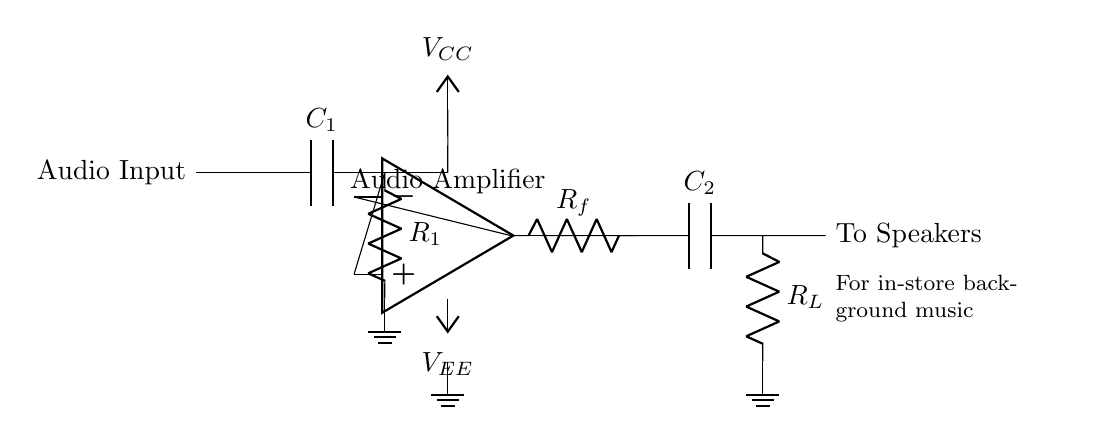What type of amplifier is shown in the circuit? The circuit diagram uses an operational amplifier, which is typically categorized as a voltage amplifier in analog circuits. This can be deduced from the presence of the op-amp symbol, indicating it amplifies the input audio signal.
Answer: operational amplifier What is the value of the input capacitance? The circuit features a capacitor labeled C1, which serves as the input capacitor. The label indicates its function in coupling the audio signal but does not specify a numerical value. Therefore, we can only describe it as capacitance without a given number.
Answer: capacitance Where do the output signals go in the circuit? The output from the op-amp is directed towards a load resistor labeled R_L. This output pathway connects to the speakers, suggesting that the final amplified audio signal is intended for playback, thus elucidating the circuit's purpose.
Answer: to speakers What is the role of the resistors R1 and Rf in this amplifier circuit? R1 serves as a biasing resistor, helping to stabilize the input to the op-amp, while Rf, the feedback resistor, determines the gain of the amplifier based on the ratio between Rf and the other resistors in the feedback loop. This relationship is essential for controlling how much the audio signal is amplified.
Answer: stabilize input and set gain Identify the power supply voltages present in the circuit. The circuit has both positive and negative power supply voltages, denoted as V_CC and V_EE, respectively. These voltages are essential for the operation of the op-amp, providing the necessary power to amplify the input audio signal.
Answer: V_CC and V_EE What is the purpose of capacitor C2 in the output stage? Capacitor C2 acts as a coupling capacitor that blocks direct current (DC) while allowing alternating current (AC) audio signals to pass through to the load resistor, thus ensuring that only the audio signal reaches the speakers without any DC offset, which could damage them.
Answer: coupling capacitor 